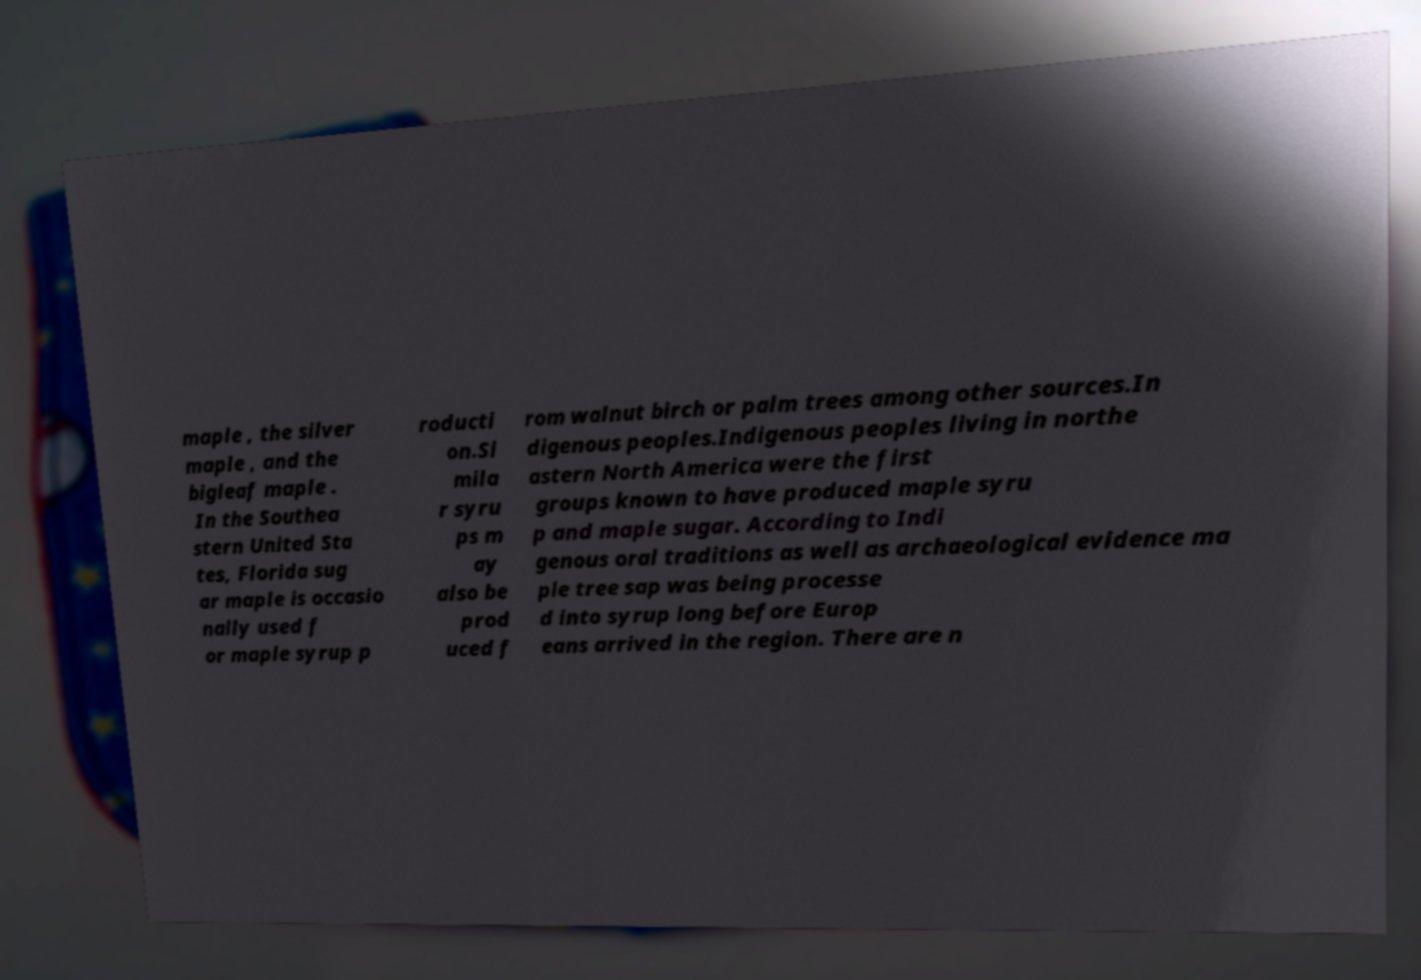What messages or text are displayed in this image? I need them in a readable, typed format. maple , the silver maple , and the bigleaf maple . In the Southea stern United Sta tes, Florida sug ar maple is occasio nally used f or maple syrup p roducti on.Si mila r syru ps m ay also be prod uced f rom walnut birch or palm trees among other sources.In digenous peoples.Indigenous peoples living in northe astern North America were the first groups known to have produced maple syru p and maple sugar. According to Indi genous oral traditions as well as archaeological evidence ma ple tree sap was being processe d into syrup long before Europ eans arrived in the region. There are n 